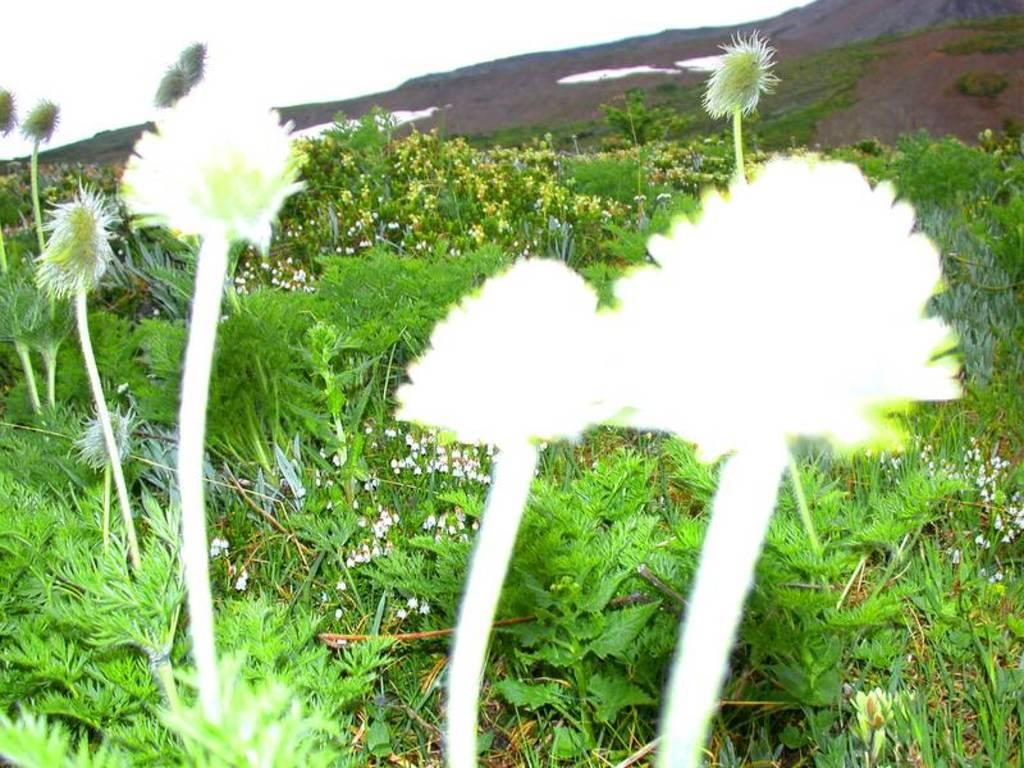What types of living organisms can be seen in the image? Plants and flowers are visible in the image. Can you describe the background of the image? The sky is visible in the background of the image. Can you see a plane flying over the seashore in the image? There is no plane or seashore present in the image; it features plants and flowers with a sky background. Is there a gate visible in the image? There is no gate present in the image. 